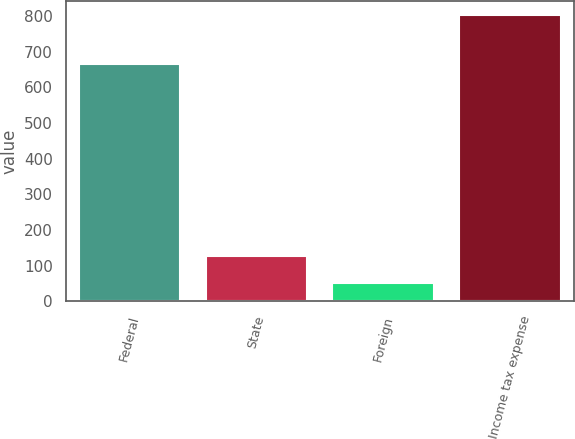<chart> <loc_0><loc_0><loc_500><loc_500><bar_chart><fcel>Federal<fcel>State<fcel>Foreign<fcel>Income tax expense<nl><fcel>666<fcel>127.9<fcel>53<fcel>802<nl></chart> 